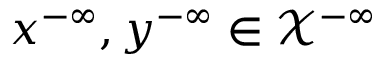<formula> <loc_0><loc_0><loc_500><loc_500>x ^ { - \infty } , y ^ { - \infty } \in \mathcal { X } ^ { - \infty }</formula> 